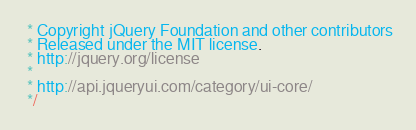<code> <loc_0><loc_0><loc_500><loc_500><_JavaScript_> * Copyright jQuery Foundation and other contributors
 * Released under the MIT license.
 * http://jquery.org/license
 *
 * http://api.jqueryui.com/category/ui-core/
 */</code> 